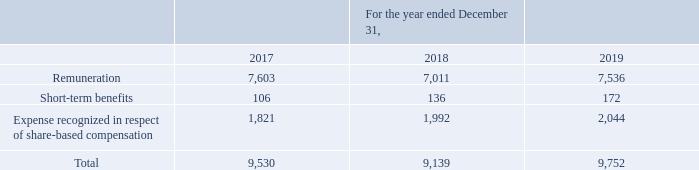GasLog Ltd. and its Subsidiaries
Notes to the consolidated financial statements (Continued)
For the years ended December 31, 2017, 2018 and 2019
(All amounts expressed in thousands of U.S. Dollars, except share and per share data)
21. Related Party Transactions (Continued)
Compensation of key management personnel
The remuneration of directors and key management was as follows:
In which years was the remuneration of directors and key management recorded for? 2017, 2018, 2019. What is the expense recognized in respect of share-based compensation in 2017?
Answer scale should be: thousand. 1,821. What was the remuneration in 2018?
Answer scale should be: thousand. 7,011. Which year was the short-term benefits the highest? 172 > 136 > 106
Answer: 2019. What was the change in the total from 2017 to 2019?
Answer scale should be: thousand. 9,752 - 9,530 
Answer: 222. What was the percentage change in remuneration from 2018 to 2019?
Answer scale should be: percent. (7,536 - 7,011)/7,011 
Answer: 7.49. 